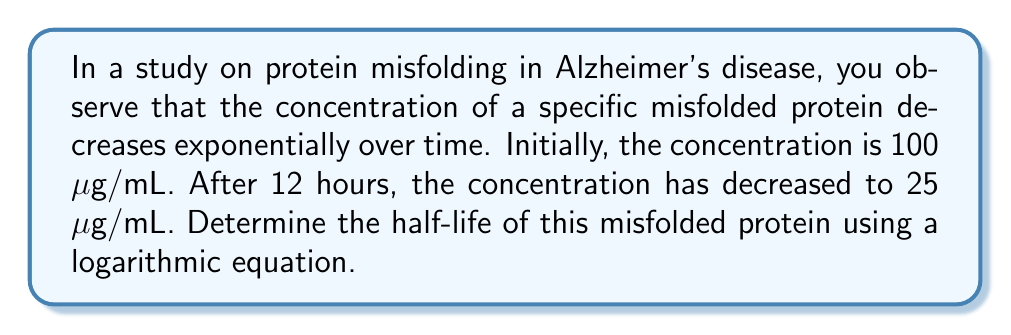Give your solution to this math problem. Let's approach this step-by-step:

1) The general equation for exponential decay is:
   $$C(t) = C_0 \cdot e^{-kt}$$
   where $C(t)$ is the concentration at time $t$, $C_0$ is the initial concentration, $k$ is the decay constant, and $t$ is time.

2) We know:
   $C_0 = 100$ μg/mL
   $C(12) = 25$ μg/mL
   $t = 12$ hours

3) Substituting these into our equation:
   $$25 = 100 \cdot e^{-12k}$$

4) Dividing both sides by 100:
   $$0.25 = e^{-12k}$$

5) Taking the natural log of both sides:
   $$\ln(0.25) = -12k$$

6) Solving for $k$:
   $$k = -\frac{\ln(0.25)}{12} \approx 0.1155$$

7) The half-life $t_{1/2}$ is the time it takes for the concentration to reduce to half. It's related to $k$ by:
   $$t_{1/2} = \frac{\ln(2)}{k}$$

8) Substituting our value for $k$:
   $$t_{1/2} = \frac{\ln(2)}{0.1155} \approx 6.00$$

Therefore, the half-life of the misfolded protein is approximately 6.00 hours.
Answer: 6.00 hours 